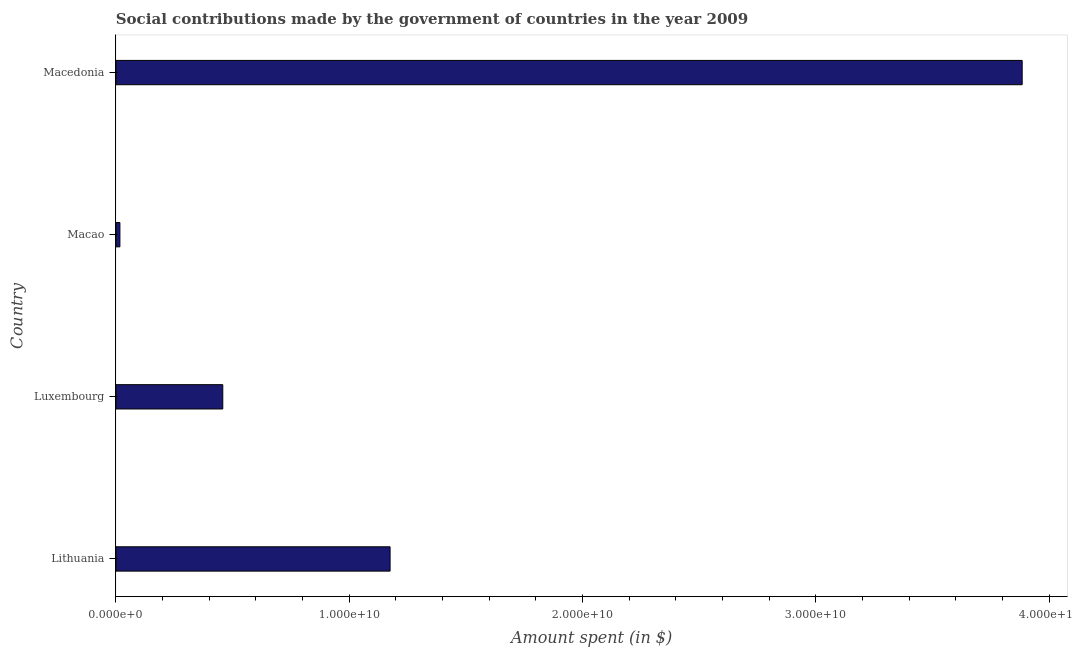What is the title of the graph?
Provide a succinct answer. Social contributions made by the government of countries in the year 2009. What is the label or title of the X-axis?
Your answer should be very brief. Amount spent (in $). What is the amount spent in making social contributions in Macedonia?
Provide a succinct answer. 3.88e+1. Across all countries, what is the maximum amount spent in making social contributions?
Make the answer very short. 3.88e+1. Across all countries, what is the minimum amount spent in making social contributions?
Give a very brief answer. 1.72e+08. In which country was the amount spent in making social contributions maximum?
Your answer should be compact. Macedonia. In which country was the amount spent in making social contributions minimum?
Ensure brevity in your answer.  Macao. What is the sum of the amount spent in making social contributions?
Your response must be concise. 5.53e+1. What is the difference between the amount spent in making social contributions in Luxembourg and Macao?
Provide a short and direct response. 4.41e+09. What is the average amount spent in making social contributions per country?
Offer a terse response. 1.38e+1. What is the median amount spent in making social contributions?
Offer a terse response. 8.17e+09. In how many countries, is the amount spent in making social contributions greater than 16000000000 $?
Give a very brief answer. 1. What is the ratio of the amount spent in making social contributions in Luxembourg to that in Macao?
Provide a short and direct response. 26.61. What is the difference between the highest and the second highest amount spent in making social contributions?
Keep it short and to the point. 2.71e+1. Is the sum of the amount spent in making social contributions in Lithuania and Macedonia greater than the maximum amount spent in making social contributions across all countries?
Offer a terse response. Yes. What is the difference between the highest and the lowest amount spent in making social contributions?
Provide a short and direct response. 3.87e+1. Are all the bars in the graph horizontal?
Make the answer very short. Yes. What is the difference between two consecutive major ticks on the X-axis?
Ensure brevity in your answer.  1.00e+1. What is the Amount spent (in $) in Lithuania?
Ensure brevity in your answer.  1.17e+1. What is the Amount spent (in $) of Luxembourg?
Make the answer very short. 4.58e+09. What is the Amount spent (in $) in Macao?
Offer a very short reply. 1.72e+08. What is the Amount spent (in $) in Macedonia?
Your response must be concise. 3.88e+1. What is the difference between the Amount spent (in $) in Lithuania and Luxembourg?
Provide a succinct answer. 7.17e+09. What is the difference between the Amount spent (in $) in Lithuania and Macao?
Your answer should be compact. 1.16e+1. What is the difference between the Amount spent (in $) in Lithuania and Macedonia?
Your answer should be compact. -2.71e+1. What is the difference between the Amount spent (in $) in Luxembourg and Macao?
Ensure brevity in your answer.  4.41e+09. What is the difference between the Amount spent (in $) in Luxembourg and Macedonia?
Your answer should be compact. -3.43e+1. What is the difference between the Amount spent (in $) in Macao and Macedonia?
Give a very brief answer. -3.87e+1. What is the ratio of the Amount spent (in $) in Lithuania to that in Luxembourg?
Keep it short and to the point. 2.56. What is the ratio of the Amount spent (in $) in Lithuania to that in Macao?
Offer a very short reply. 68.25. What is the ratio of the Amount spent (in $) in Lithuania to that in Macedonia?
Keep it short and to the point. 0.3. What is the ratio of the Amount spent (in $) in Luxembourg to that in Macao?
Offer a very short reply. 26.61. What is the ratio of the Amount spent (in $) in Luxembourg to that in Macedonia?
Offer a terse response. 0.12. What is the ratio of the Amount spent (in $) in Macao to that in Macedonia?
Provide a short and direct response. 0. 